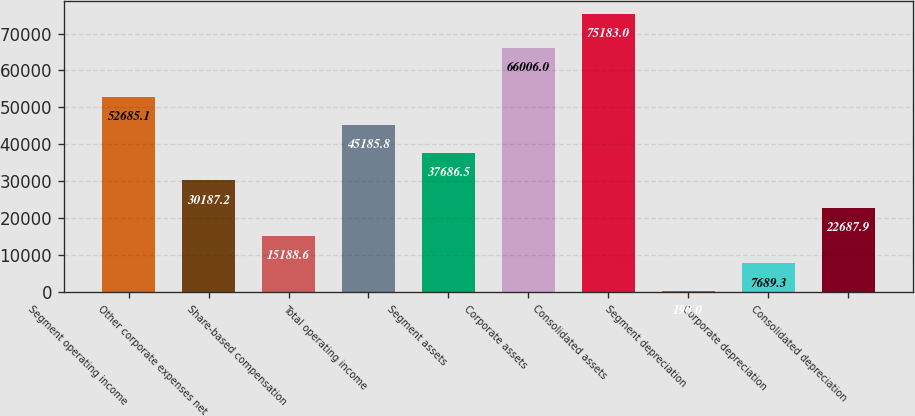<chart> <loc_0><loc_0><loc_500><loc_500><bar_chart><fcel>Segment operating income<fcel>Other corporate expenses net<fcel>Share-based compensation<fcel>Total operating income<fcel>Segment assets<fcel>Corporate assets<fcel>Consolidated assets<fcel>Segment depreciation<fcel>Corporate depreciation<fcel>Consolidated depreciation<nl><fcel>52685.1<fcel>30187.2<fcel>15188.6<fcel>45185.8<fcel>37686.5<fcel>66006<fcel>75183<fcel>190<fcel>7689.3<fcel>22687.9<nl></chart> 